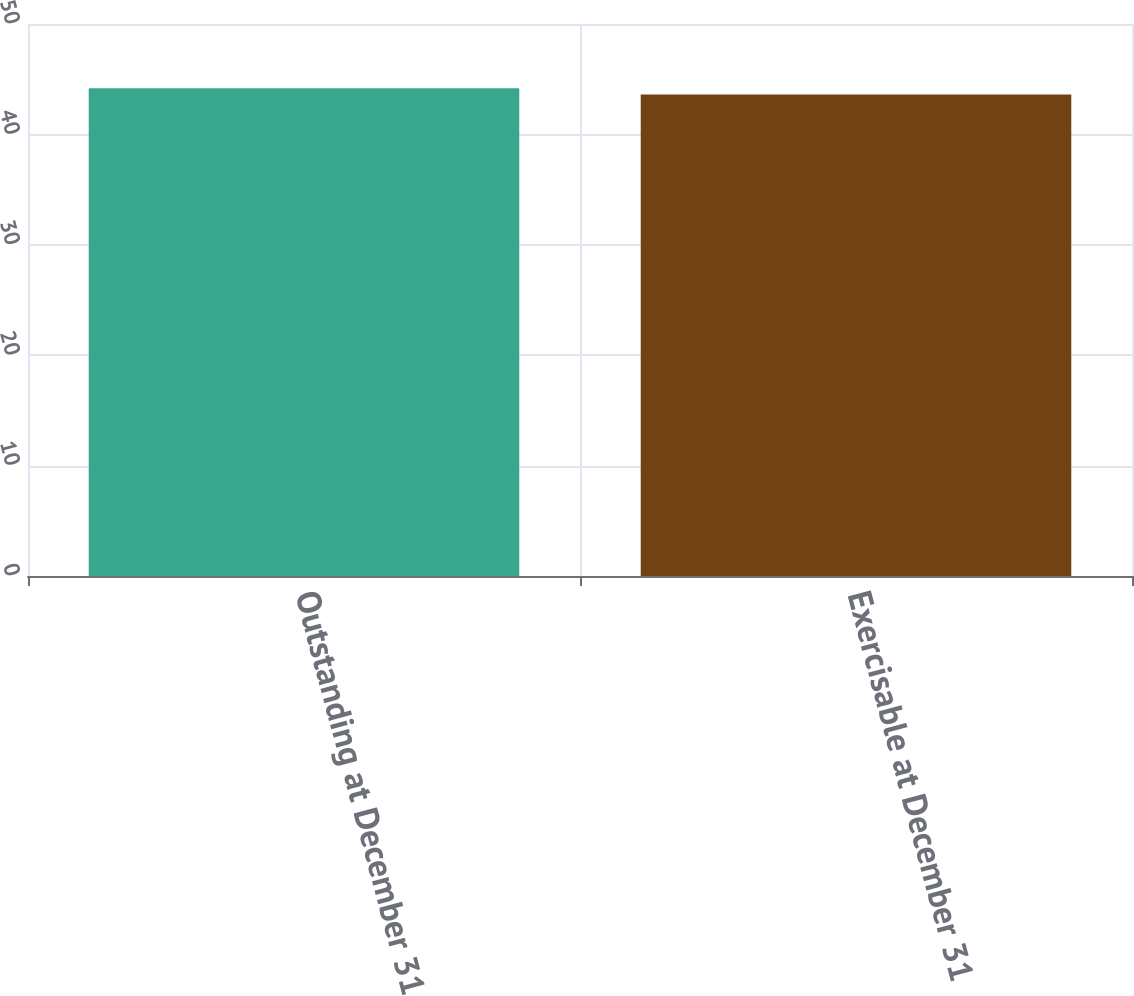Convert chart. <chart><loc_0><loc_0><loc_500><loc_500><bar_chart><fcel>Outstanding at December 31<fcel>Exercisable at December 31<nl><fcel>44.18<fcel>43.62<nl></chart> 